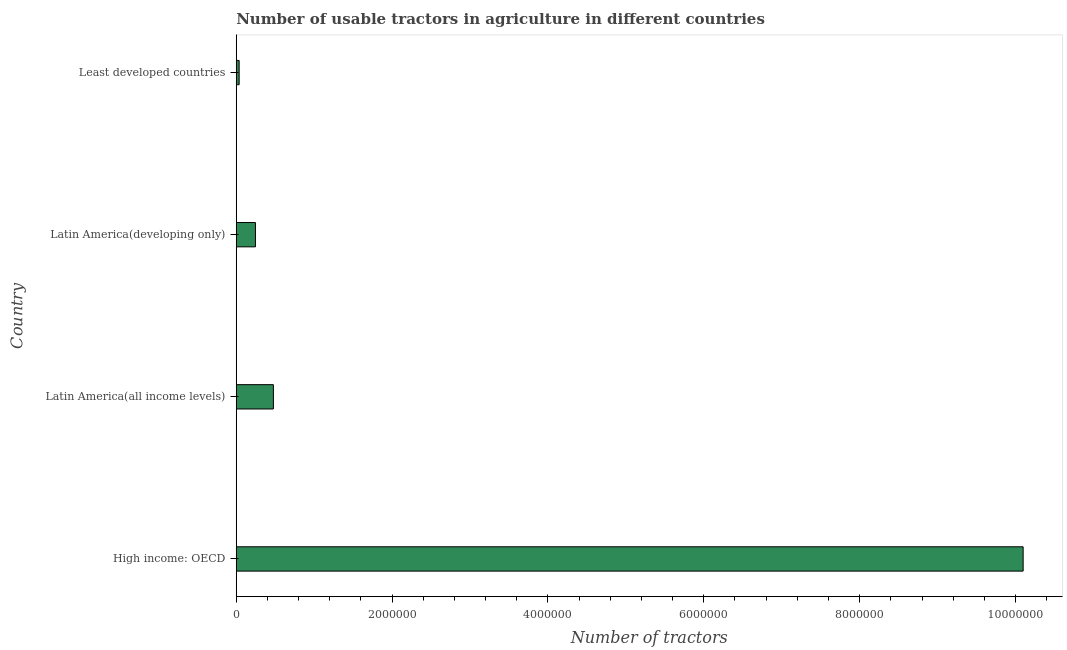What is the title of the graph?
Your response must be concise. Number of usable tractors in agriculture in different countries. What is the label or title of the X-axis?
Give a very brief answer. Number of tractors. What is the number of tractors in High income: OECD?
Provide a short and direct response. 1.01e+07. Across all countries, what is the maximum number of tractors?
Offer a terse response. 1.01e+07. Across all countries, what is the minimum number of tractors?
Your response must be concise. 3.71e+04. In which country was the number of tractors maximum?
Your response must be concise. High income: OECD. In which country was the number of tractors minimum?
Your answer should be compact. Least developed countries. What is the sum of the number of tractors?
Offer a very short reply. 1.09e+07. What is the difference between the number of tractors in Latin America(all income levels) and Least developed countries?
Offer a very short reply. 4.39e+05. What is the average number of tractors per country?
Offer a terse response. 2.71e+06. What is the median number of tractors?
Offer a terse response. 3.61e+05. What is the ratio of the number of tractors in Latin America(developing only) to that in Least developed countries?
Your response must be concise. 6.64. Is the difference between the number of tractors in High income: OECD and Latin America(developing only) greater than the difference between any two countries?
Provide a succinct answer. No. What is the difference between the highest and the second highest number of tractors?
Keep it short and to the point. 9.62e+06. What is the difference between the highest and the lowest number of tractors?
Make the answer very short. 1.01e+07. How many bars are there?
Provide a short and direct response. 4. Are all the bars in the graph horizontal?
Your answer should be very brief. Yes. How many countries are there in the graph?
Your response must be concise. 4. What is the difference between two consecutive major ticks on the X-axis?
Your response must be concise. 2.00e+06. Are the values on the major ticks of X-axis written in scientific E-notation?
Give a very brief answer. No. What is the Number of tractors in High income: OECD?
Your answer should be compact. 1.01e+07. What is the Number of tractors in Latin America(all income levels)?
Your answer should be very brief. 4.77e+05. What is the Number of tractors of Latin America(developing only)?
Provide a succinct answer. 2.46e+05. What is the Number of tractors of Least developed countries?
Provide a succinct answer. 3.71e+04. What is the difference between the Number of tractors in High income: OECD and Latin America(all income levels)?
Your answer should be compact. 9.62e+06. What is the difference between the Number of tractors in High income: OECD and Latin America(developing only)?
Provide a succinct answer. 9.85e+06. What is the difference between the Number of tractors in High income: OECD and Least developed countries?
Provide a succinct answer. 1.01e+07. What is the difference between the Number of tractors in Latin America(all income levels) and Latin America(developing only)?
Offer a very short reply. 2.30e+05. What is the difference between the Number of tractors in Latin America(all income levels) and Least developed countries?
Give a very brief answer. 4.39e+05. What is the difference between the Number of tractors in Latin America(developing only) and Least developed countries?
Your response must be concise. 2.09e+05. What is the ratio of the Number of tractors in High income: OECD to that in Latin America(all income levels)?
Your answer should be very brief. 21.19. What is the ratio of the Number of tractors in High income: OECD to that in Latin America(developing only)?
Make the answer very short. 41.01. What is the ratio of the Number of tractors in High income: OECD to that in Least developed countries?
Offer a terse response. 272.23. What is the ratio of the Number of tractors in Latin America(all income levels) to that in Latin America(developing only)?
Offer a very short reply. 1.94. What is the ratio of the Number of tractors in Latin America(all income levels) to that in Least developed countries?
Give a very brief answer. 12.85. What is the ratio of the Number of tractors in Latin America(developing only) to that in Least developed countries?
Make the answer very short. 6.64. 